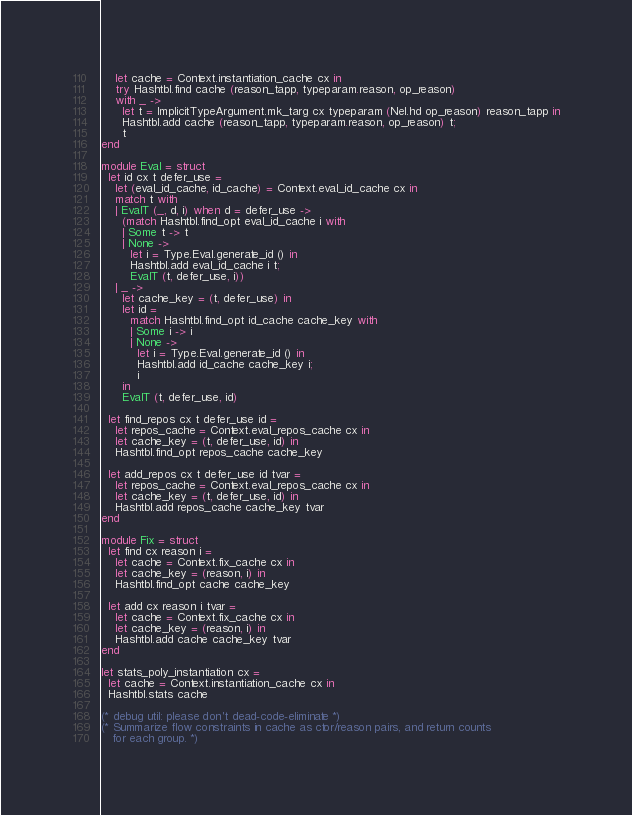Convert code to text. <code><loc_0><loc_0><loc_500><loc_500><_OCaml_>    let cache = Context.instantiation_cache cx in
    try Hashtbl.find cache (reason_tapp, typeparam.reason, op_reason)
    with _ ->
      let t = ImplicitTypeArgument.mk_targ cx typeparam (Nel.hd op_reason) reason_tapp in
      Hashtbl.add cache (reason_tapp, typeparam.reason, op_reason) t;
      t
end

module Eval = struct
  let id cx t defer_use =
    let (eval_id_cache, id_cache) = Context.eval_id_cache cx in
    match t with
    | EvalT (_, d, i) when d = defer_use ->
      (match Hashtbl.find_opt eval_id_cache i with
      | Some t -> t
      | None ->
        let i = Type.Eval.generate_id () in
        Hashtbl.add eval_id_cache i t;
        EvalT (t, defer_use, i))
    | _ ->
      let cache_key = (t, defer_use) in
      let id =
        match Hashtbl.find_opt id_cache cache_key with
        | Some i -> i
        | None ->
          let i = Type.Eval.generate_id () in
          Hashtbl.add id_cache cache_key i;
          i
      in
      EvalT (t, defer_use, id)

  let find_repos cx t defer_use id =
    let repos_cache = Context.eval_repos_cache cx in
    let cache_key = (t, defer_use, id) in
    Hashtbl.find_opt repos_cache cache_key

  let add_repos cx t defer_use id tvar =
    let repos_cache = Context.eval_repos_cache cx in
    let cache_key = (t, defer_use, id) in
    Hashtbl.add repos_cache cache_key tvar
end

module Fix = struct
  let find cx reason i =
    let cache = Context.fix_cache cx in
    let cache_key = (reason, i) in
    Hashtbl.find_opt cache cache_key

  let add cx reason i tvar =
    let cache = Context.fix_cache cx in
    let cache_key = (reason, i) in
    Hashtbl.add cache cache_key tvar
end

let stats_poly_instantiation cx =
  let cache = Context.instantiation_cache cx in
  Hashtbl.stats cache

(* debug util: please don't dead-code-eliminate *)
(* Summarize flow constraints in cache as ctor/reason pairs, and return counts
   for each group. *)</code> 